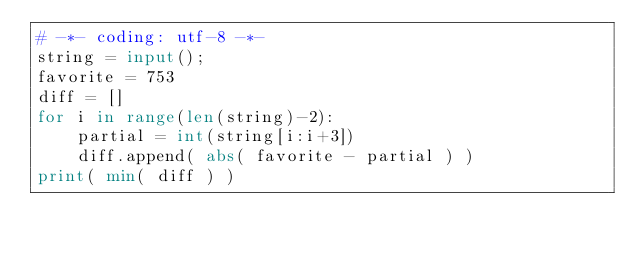Convert code to text. <code><loc_0><loc_0><loc_500><loc_500><_Python_># -*- coding: utf-8 -*-
string = input();
favorite = 753
diff = []
for i in range(len(string)-2):
    partial = int(string[i:i+3])
    diff.append( abs( favorite - partial ) )
print( min( diff ) )</code> 